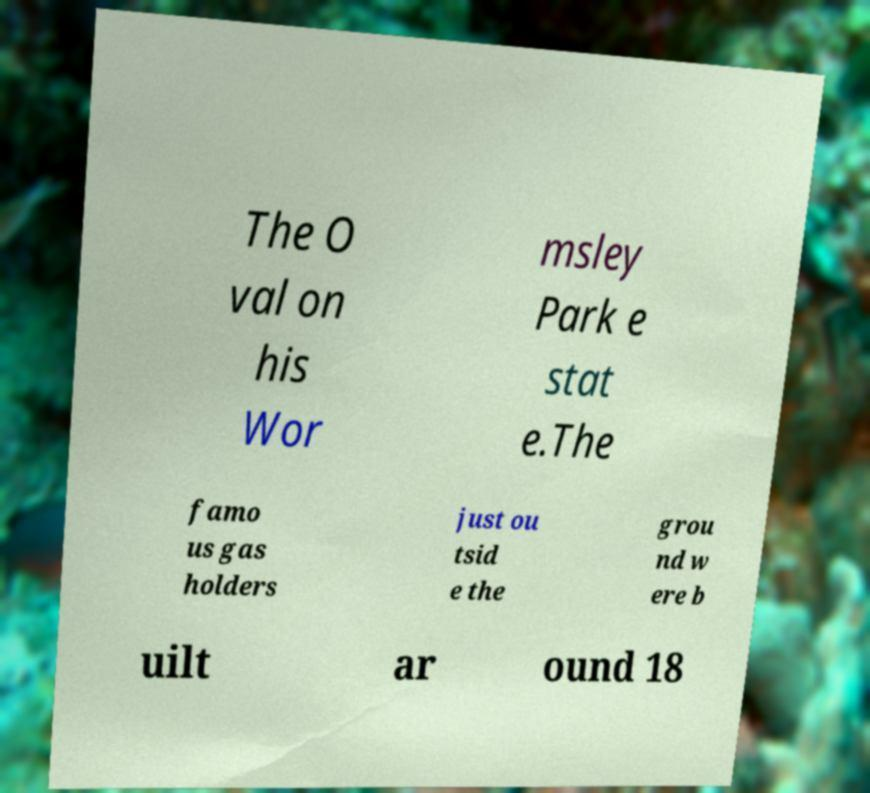For documentation purposes, I need the text within this image transcribed. Could you provide that? The O val on his Wor msley Park e stat e.The famo us gas holders just ou tsid e the grou nd w ere b uilt ar ound 18 